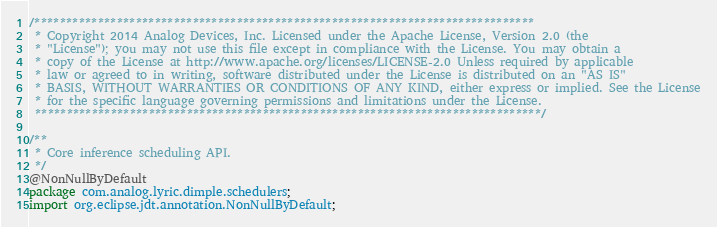<code> <loc_0><loc_0><loc_500><loc_500><_Java_>/*******************************************************************************
 * Copyright 2014 Analog Devices, Inc. Licensed under the Apache License, Version 2.0 (the
 * "License"); you may not use this file except in compliance with the License. You may obtain a
 * copy of the License at http://www.apache.org/licenses/LICENSE-2.0 Unless required by applicable
 * law or agreed to in writing, software distributed under the License is distributed on an "AS IS"
 * BASIS, WITHOUT WARRANTIES OR CONDITIONS OF ANY KIND, either express or implied. See the License
 * for the specific language governing permissions and limitations under the License.
 ********************************************************************************/

/**
 * Core inference scheduling API.
 */
@NonNullByDefault
package com.analog.lyric.dimple.schedulers;
import org.eclipse.jdt.annotation.NonNullByDefault;

</code> 